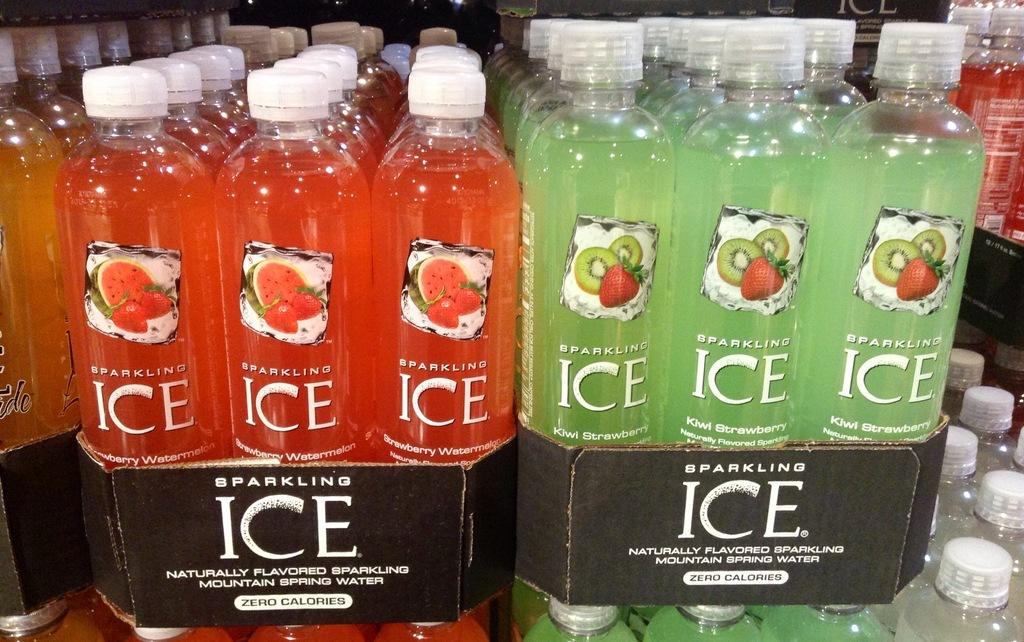<image>
Write a terse but informative summary of the picture. Packs of Sparkling Ice bottled water with zero calories. 